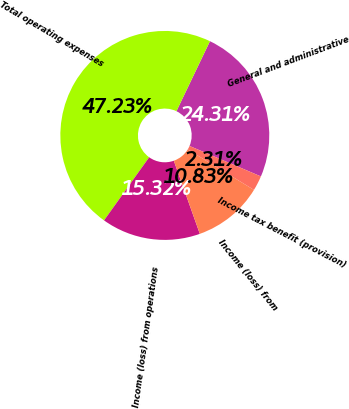Convert chart to OTSL. <chart><loc_0><loc_0><loc_500><loc_500><pie_chart><fcel>General and administrative<fcel>Total operating expenses<fcel>Income (loss) from operations<fcel>Income (loss) from<fcel>Income tax benefit (provision)<nl><fcel>24.31%<fcel>47.23%<fcel>15.32%<fcel>10.83%<fcel>2.31%<nl></chart> 